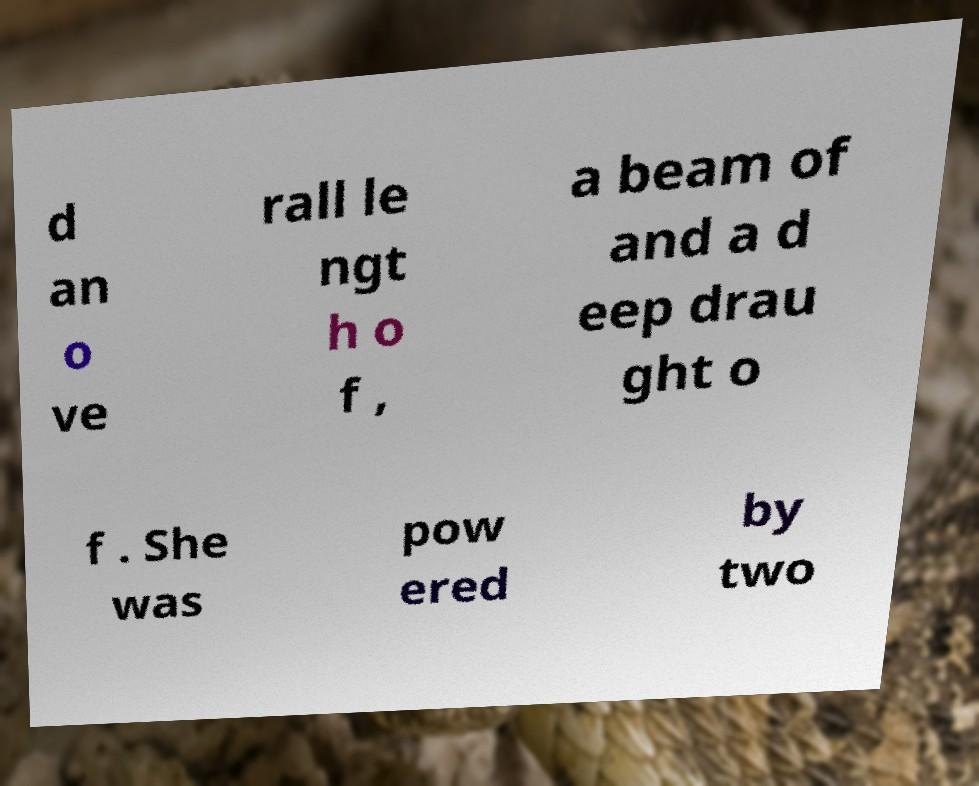Can you accurately transcribe the text from the provided image for me? d an o ve rall le ngt h o f , a beam of and a d eep drau ght o f . She was pow ered by two 